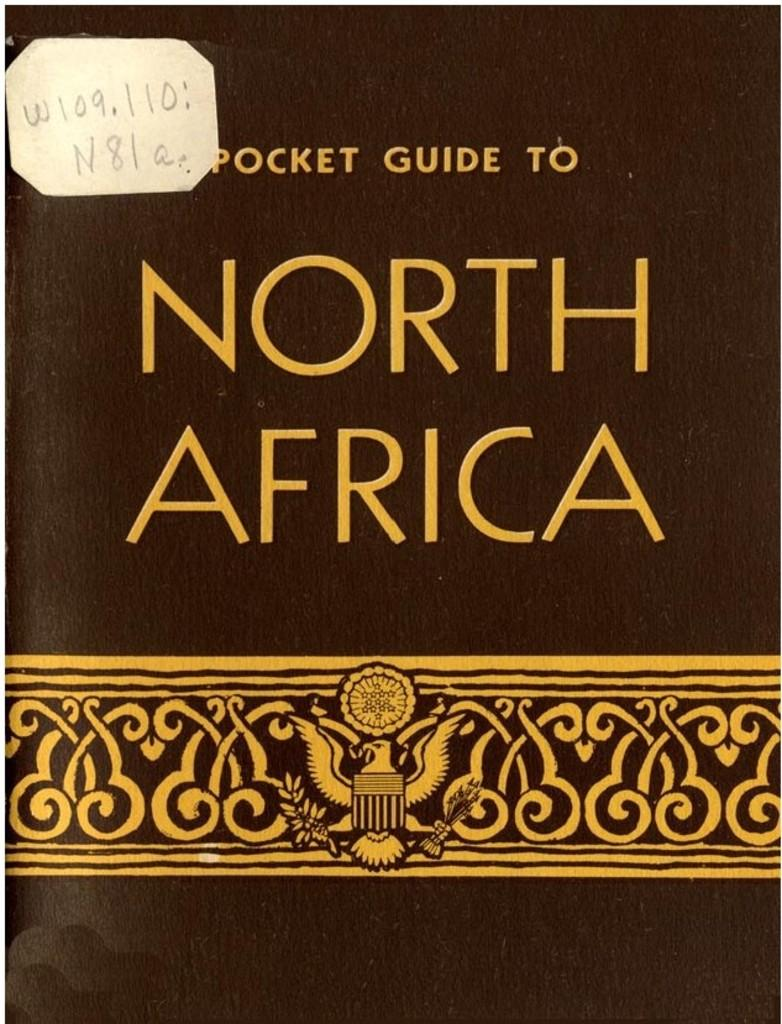Provide a one-sentence caption for the provided image. A black book called Pocket Guide to North Africa. 